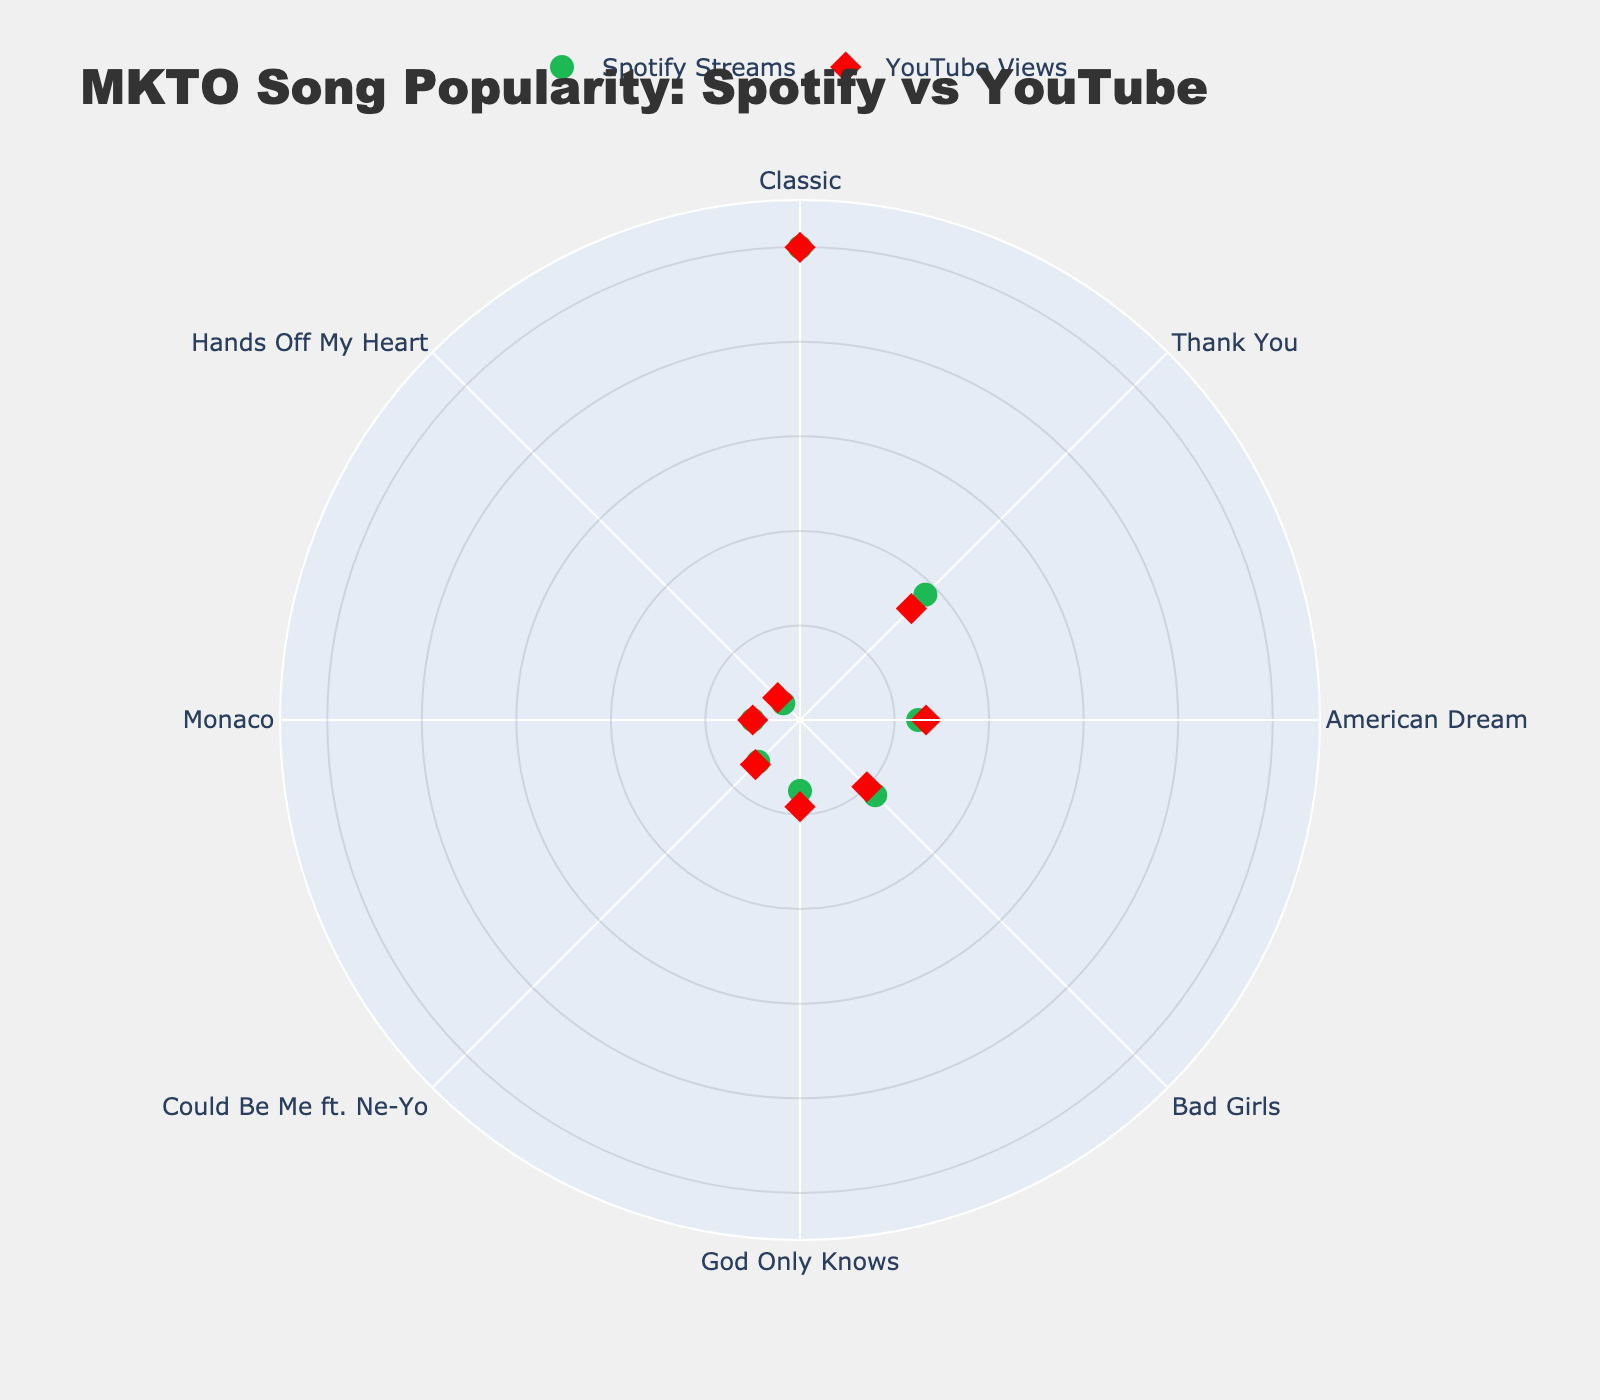What is the title of the chart? The title of the chart is displayed at the top. It reads "MKTO Song Popularity: Spotify vs YouTube."
Answer: MKTO Song Popularity: Spotify vs YouTube How many songs are represented in this chart? The chart displays each song's name around the polar axis. Counting these names, there are 8 songs represented.
Answer: 8 Which song has the highest Spotify streams? Find the song with the marker furthest from the center on the "Spotify Streams" series (green circles). "Classic" is the furthest.
Answer: Classic How do 'American Dream' and 'Bad Girls' compare in YouTube views? Locate the markers for 'American Dream' and 'Bad Girls' on the "YouTube Views" series (red diamonds). 'American Dream' (80M views) is further from the center compared to 'Bad Girls' (60M views).
Answer: American Dream has more views Which song has the fewest Spotify streams? Find the song with the marker closest to the center on the "Spotify Streams" series. "Hands Off My Heart" is the closest.
Answer: Hands Off My Heart What is the normalized value of 'God Only Knows' for Spotify streams? Find 'God Only Knows' on the "Spotify Streams" series (green circles) and read the radial distance. It corresponds to 30M streams which is normalized to 30/200 = 0.15.
Answer: 0.15 What is the difference in normalized YouTube views between 'Monaco' and 'Thank You'? Find 'Monaco' (30M views) and 'Thank You' (100M views) on the "YouTube Views" series (red diamonds). Their normalized values are 30/300 = 0.1 and 100/300 = 0.333. The difference is 0.333 - 0.1 = 0.233.
Answer: 0.233 Which songs have higher YouTube views than Spotify streams? Compare the positions of each song's green circle (Spotify) and red diamond (YouTube). Songs where the red diamond is farther from the center than the green circle have higher YouTube views. These songs are "Classic," "American Dream," and "God Only Knows."
Answer: Classic, American Dream, God Only Knows Which song is closest to "Thank You" in Spotify streams but not in YouTube views? Identify the neighboring markers of "Thank You" (75M streams) in the "Spotify Streams" series. "American Dream" (50M) is closest. For YouTube views, the nearest markers to "Thank You" (100M views) are different ("American Dream" has fewer views).
Answer: American Dream 